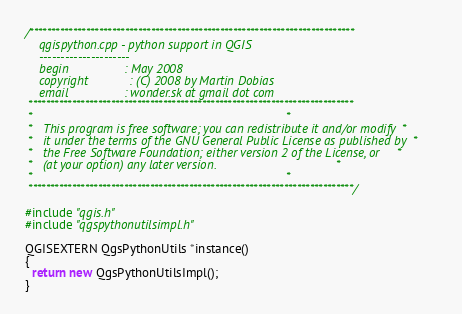Convert code to text. <code><loc_0><loc_0><loc_500><loc_500><_C++_>/***************************************************************************
    qgispython.cpp - python support in QGIS
    ---------------------
    begin                : May 2008
    copyright            : (C) 2008 by Martin Dobias
    email                : wonder.sk at gmail dot com
 ***************************************************************************
 *                                                                         *
 *   This program is free software; you can redistribute it and/or modify  *
 *   it under the terms of the GNU General Public License as published by  *
 *   the Free Software Foundation; either version 2 of the License, or     *
 *   (at your option) any later version.                                   *
 *                                                                         *
 ***************************************************************************/

#include "qgis.h"
#include "qgspythonutilsimpl.h"

QGISEXTERN QgsPythonUtils *instance()
{
  return new QgsPythonUtilsImpl();
}
</code> 